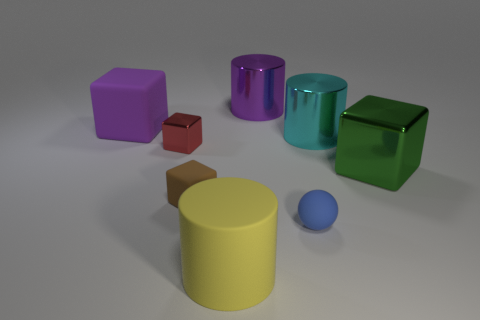How many things are both to the left of the tiny blue rubber ball and in front of the tiny brown matte object? Upon reviewing the image, there is one item that satisfies both conditions of being to the left of the tiny blue rubber ball and in front of the tiny brown matte object. It appears to be the purple block. This establishes the spatial relationships between the objects and emphasizes the accuracy of identifying one object that meets both criteria. 